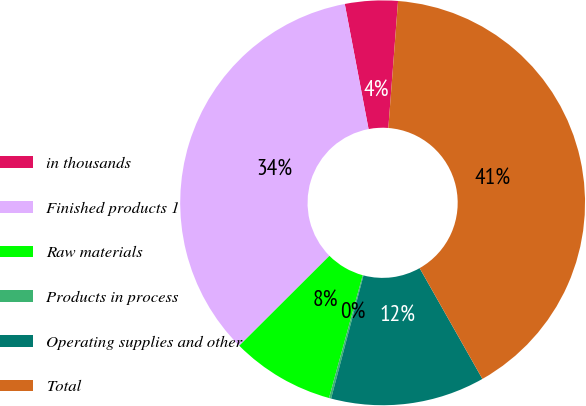<chart> <loc_0><loc_0><loc_500><loc_500><pie_chart><fcel>in thousands<fcel>Finished products 1<fcel>Raw materials<fcel>Products in process<fcel>Operating supplies and other<fcel>Total<nl><fcel>4.21%<fcel>34.48%<fcel>8.26%<fcel>0.17%<fcel>12.3%<fcel>40.58%<nl></chart> 